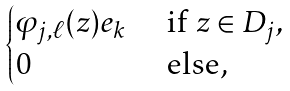<formula> <loc_0><loc_0><loc_500><loc_500>\begin{cases} \varphi _ { j , \ell } ( z ) e _ { k } & \text { if } z \in D _ { j } , \\ 0 & \text { else, } \end{cases}</formula> 